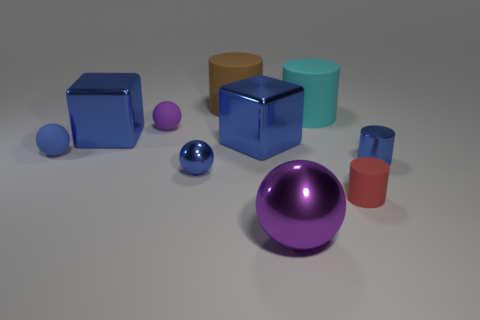There is a blue rubber object; is it the same size as the blue cube left of the tiny purple rubber object?
Provide a succinct answer. No. How many things are small blue metallic things to the right of the cyan matte cylinder or tiny blue objects that are on the right side of the big brown cylinder?
Provide a succinct answer. 1. There is a brown object that is the same size as the cyan cylinder; what shape is it?
Your response must be concise. Cylinder. What is the shape of the big purple object that is in front of the blue object that is in front of the tiny shiny cylinder behind the large purple metallic ball?
Provide a succinct answer. Sphere. Are there the same number of tiny rubber objects that are in front of the large purple sphere and gray shiny balls?
Keep it short and to the point. Yes. Do the red matte cylinder and the brown object have the same size?
Provide a short and direct response. No. What number of metallic things are either large spheres or small yellow blocks?
Provide a succinct answer. 1. There is a blue ball that is the same size as the blue rubber object; what material is it?
Give a very brief answer. Metal. What number of other things are the same material as the brown cylinder?
Your answer should be very brief. 4. Is the number of rubber objects that are behind the metal cylinder less than the number of large yellow shiny balls?
Provide a short and direct response. No. 